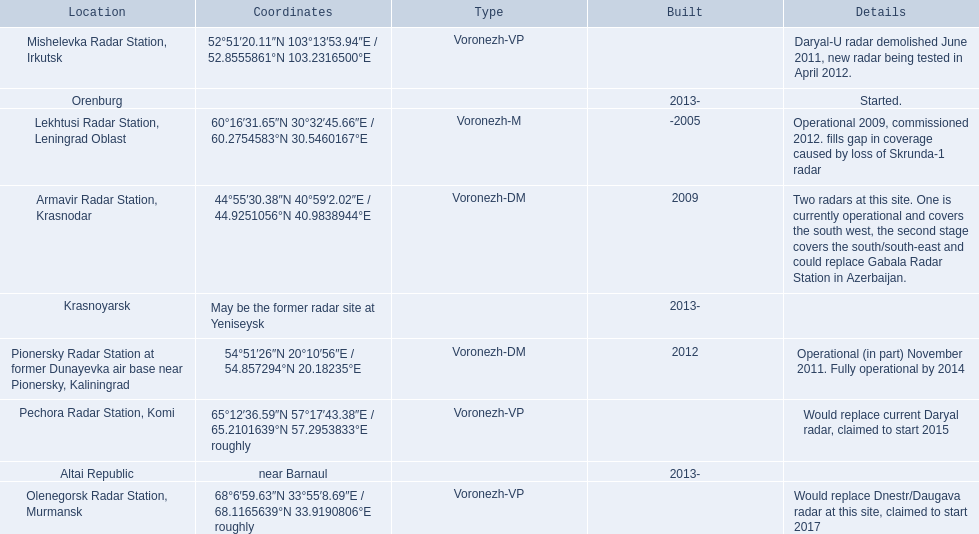What are all of the locations? Lekhtusi Radar Station, Leningrad Oblast, Armavir Radar Station, Krasnodar, Pionersky Radar Station at former Dunayevka air base near Pionersky, Kaliningrad, Mishelevka Radar Station, Irkutsk, Pechora Radar Station, Komi, Olenegorsk Radar Station, Murmansk, Krasnoyarsk, Altai Republic, Orenburg. And which location's coordinates are 60deg16'31.65''n 30deg32'45.66''e / 60.2754583degn 30.5460167dege? Lekhtusi Radar Station, Leningrad Oblast. 